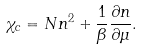Convert formula to latex. <formula><loc_0><loc_0><loc_500><loc_500>\chi _ { c } = N n ^ { 2 } + \frac { 1 } { \beta } \frac { \partial n } { \partial \mu } .</formula> 